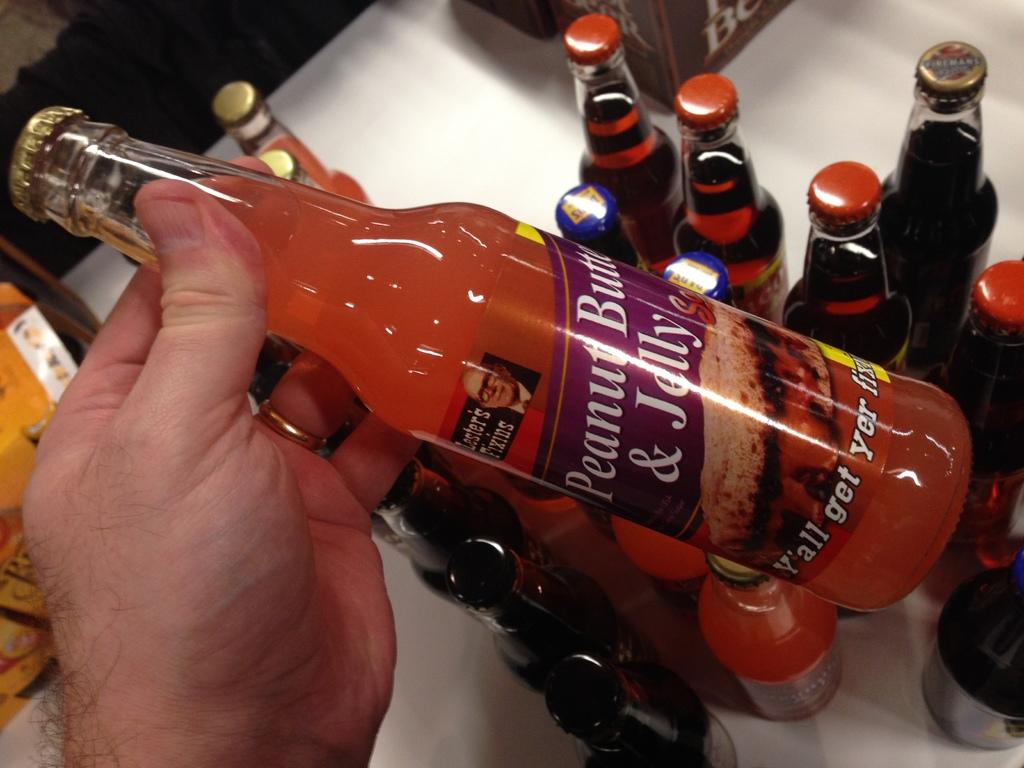<image>
Render a clear and concise summary of the photo. A bottle is labeled Peanut Butter and Jelly. 